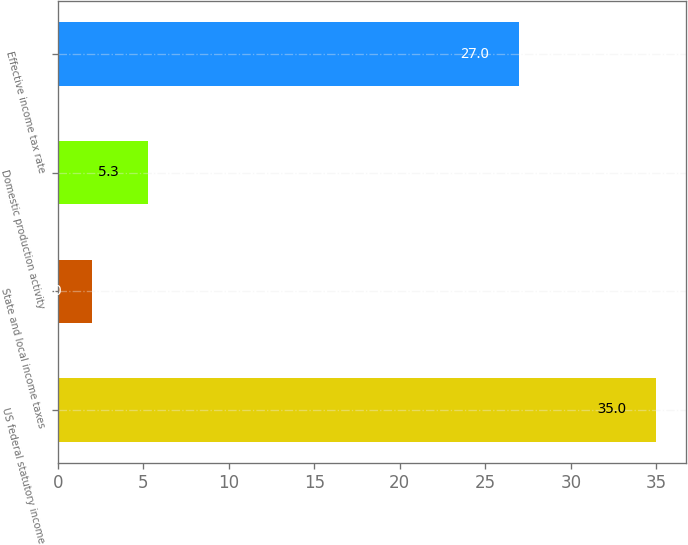Convert chart. <chart><loc_0><loc_0><loc_500><loc_500><bar_chart><fcel>US federal statutory income<fcel>State and local income taxes<fcel>Domestic production activity<fcel>Effective income tax rate<nl><fcel>35<fcel>2<fcel>5.3<fcel>27<nl></chart> 